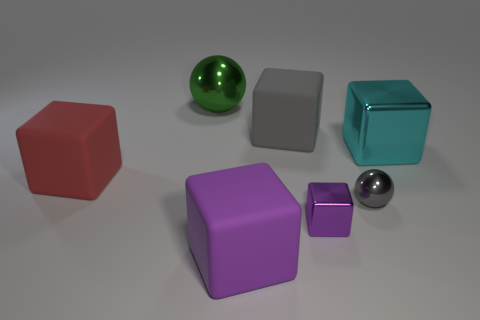Is the size of the gray shiny ball the same as the green ball? Upon closer inspection of the image, the gray shiny ball is slightly smaller in size when compared to the green ball. This difference in size is subtle, but noticeable when looking at their placement relative to other objects in the scene. 